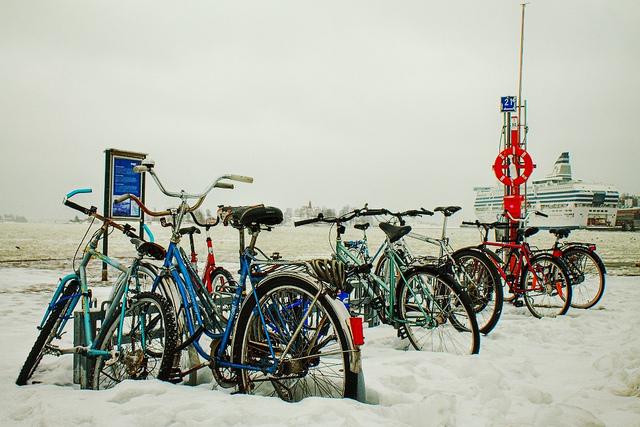How many bikes are in the picture?
Write a very short answer. 8. Is this near water?
Concise answer only. Yes. Are there riders on these bicycles?
Write a very short answer. No. How many bikes are there?
Give a very brief answer. 8. 